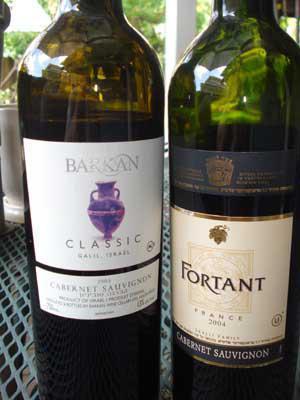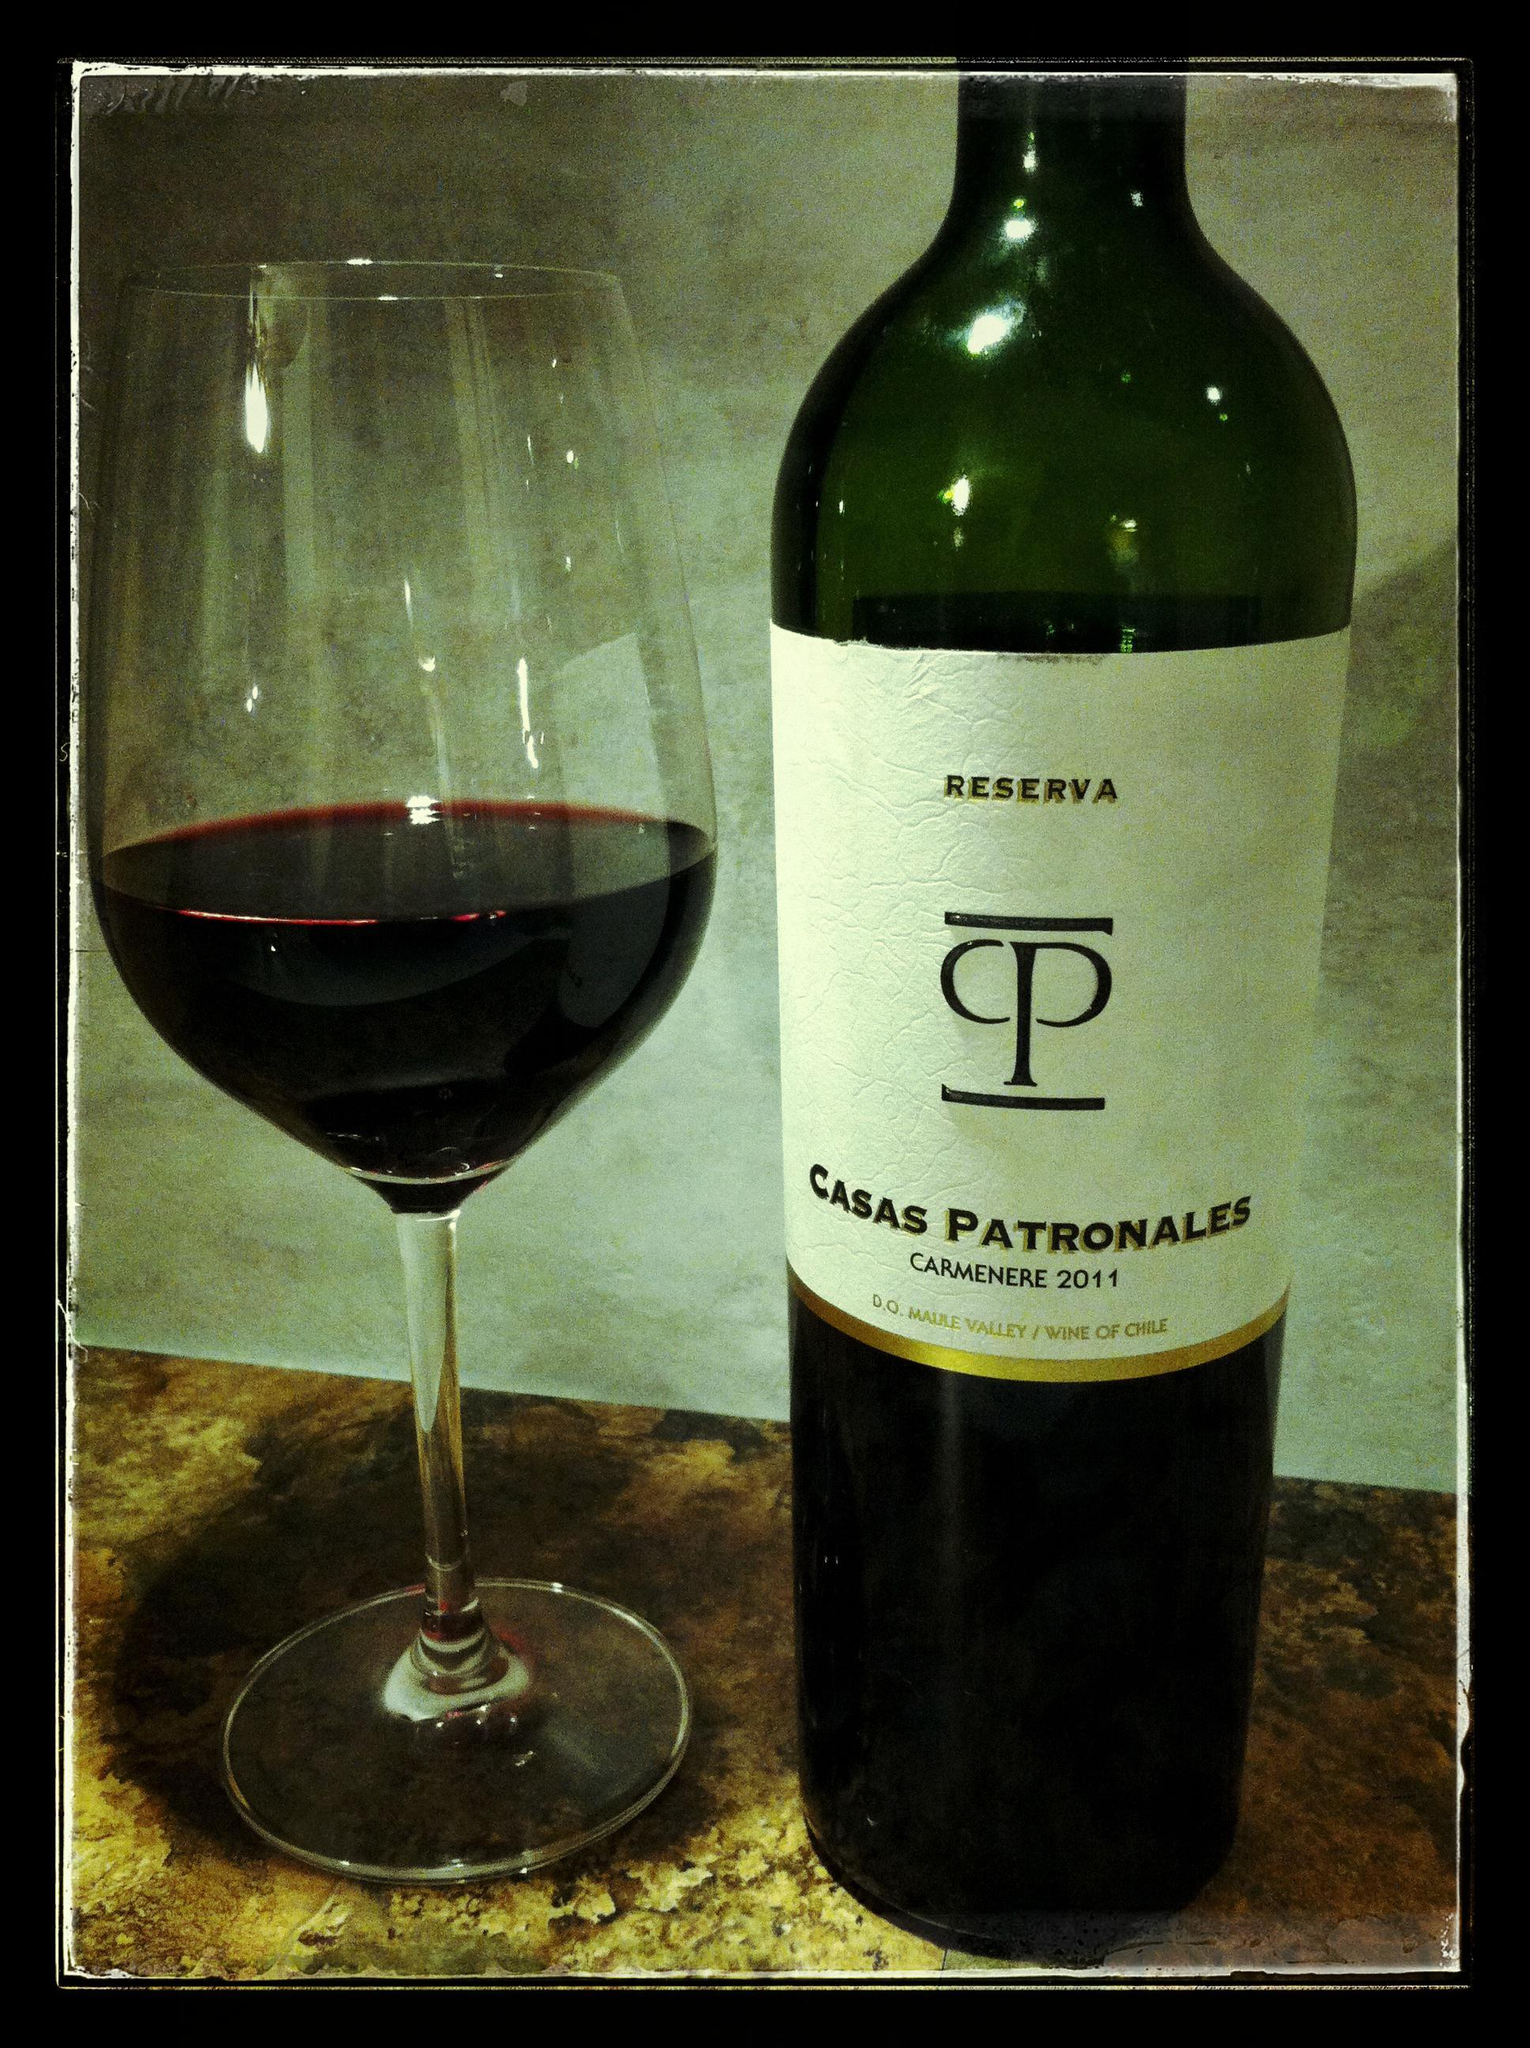The first image is the image on the left, the second image is the image on the right. Examine the images to the left and right. Is the description "there is a half filled wine glas next to a wine bottle" accurate? Answer yes or no. Yes. 